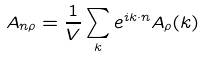Convert formula to latex. <formula><loc_0><loc_0><loc_500><loc_500>A _ { n \rho } = \frac { 1 } { V } \sum _ { k } e ^ { i k \cdot n } A _ { \rho } ( k )</formula> 